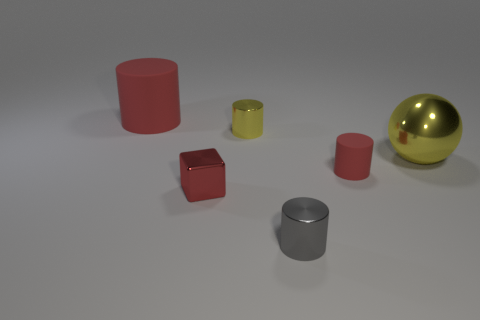What is the shape of the tiny red object on the left side of the tiny gray thing?
Give a very brief answer. Cube. There is a tiny cylinder that is the same color as the cube; what is its material?
Provide a succinct answer. Rubber. What number of other things are made of the same material as the large yellow ball?
Provide a short and direct response. 3. There is a gray metallic thing; does it have the same shape as the big thing on the right side of the small matte cylinder?
Ensure brevity in your answer.  No. There is a tiny yellow thing that is the same material as the tiny block; what is its shape?
Your answer should be compact. Cylinder. Are there more matte cylinders on the left side of the big red cylinder than small cubes behind the small red cylinder?
Provide a short and direct response. No. How many things are either tiny yellow cylinders or tiny gray shiny cylinders?
Your answer should be compact. 2. What number of other things are there of the same color as the tiny cube?
Ensure brevity in your answer.  2. What shape is the yellow metallic object that is the same size as the red shiny cube?
Ensure brevity in your answer.  Cylinder. What is the color of the rubber cylinder that is right of the gray metallic cylinder?
Give a very brief answer. Red. 